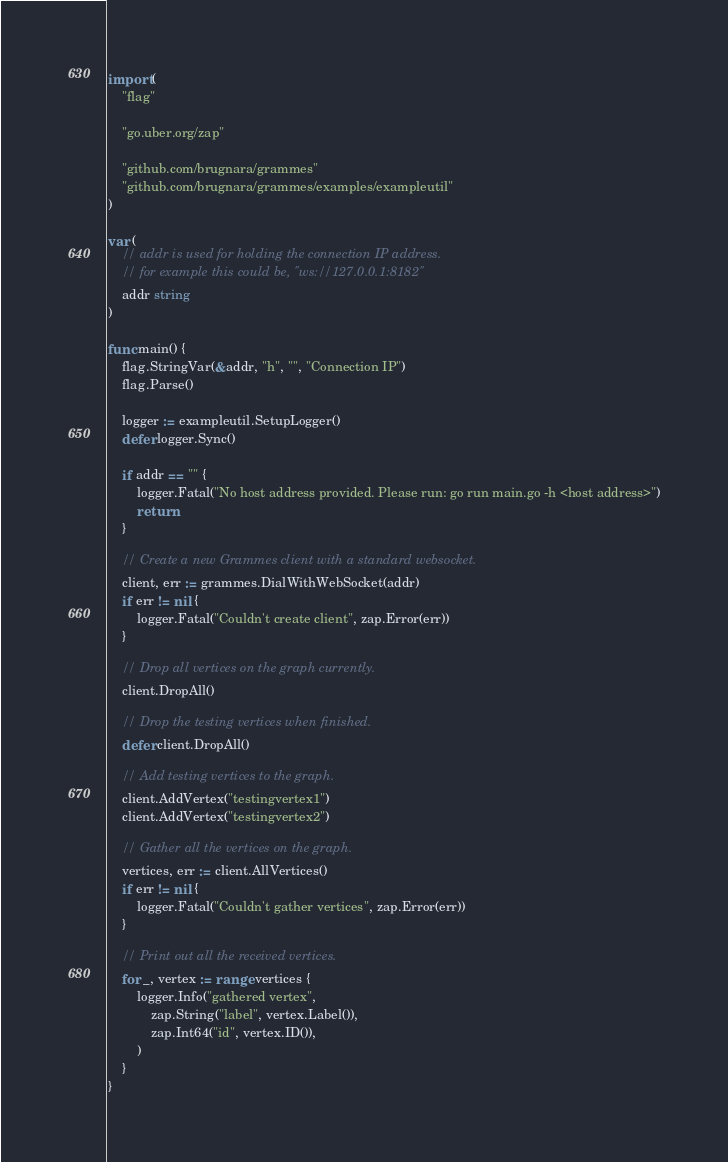<code> <loc_0><loc_0><loc_500><loc_500><_Go_>import (
	"flag"

	"go.uber.org/zap"

	"github.com/brugnara/grammes"
	"github.com/brugnara/grammes/examples/exampleutil"
)

var (
	// addr is used for holding the connection IP address.
	// for example this could be, "ws://127.0.0.1:8182"
	addr string
)

func main() {
	flag.StringVar(&addr, "h", "", "Connection IP")
	flag.Parse()

	logger := exampleutil.SetupLogger()
	defer logger.Sync()

	if addr == "" {
		logger.Fatal("No host address provided. Please run: go run main.go -h <host address>")
		return
	}

	// Create a new Grammes client with a standard websocket.
	client, err := grammes.DialWithWebSocket(addr)
	if err != nil {
		logger.Fatal("Couldn't create client", zap.Error(err))
	}

	// Drop all vertices on the graph currently.
	client.DropAll()

	// Drop the testing vertices when finished.
	defer client.DropAll()

	// Add testing vertices to the graph.
	client.AddVertex("testingvertex1")
	client.AddVertex("testingvertex2")

	// Gather all the vertices on the graph.
	vertices, err := client.AllVertices()
	if err != nil {
		logger.Fatal("Couldn't gather vertices", zap.Error(err))
	}

	// Print out all the received vertices.
	for _, vertex := range vertices {
		logger.Info("gathered vertex",
			zap.String("label", vertex.Label()),
			zap.Int64("id", vertex.ID()),
		)
	}
}
</code> 